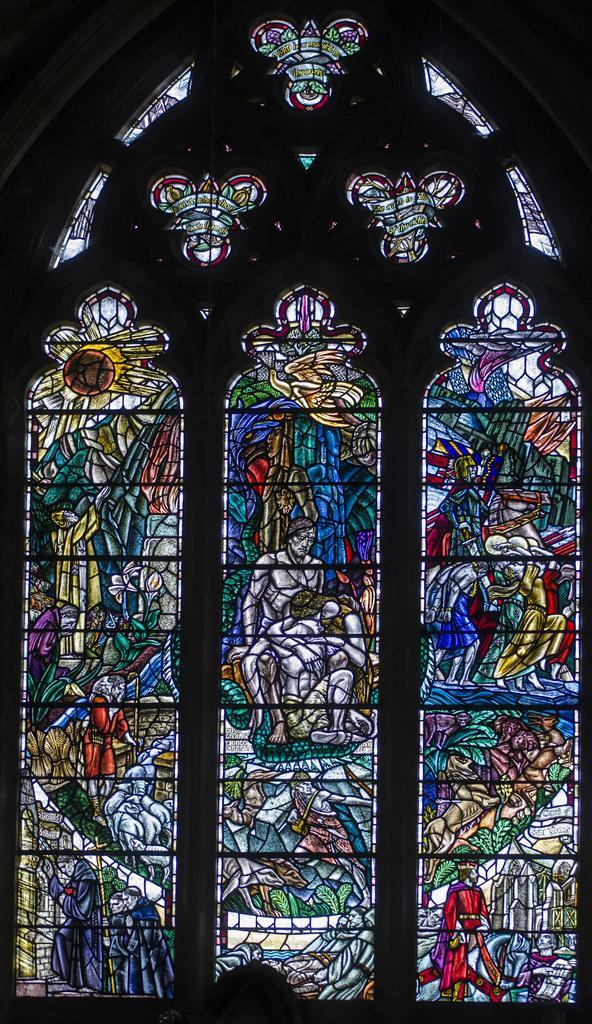Could you give a brief overview of what you see in this image? In this picture I can observe stained glass. I can observe blue, red, yellow and green colors on the glass. 